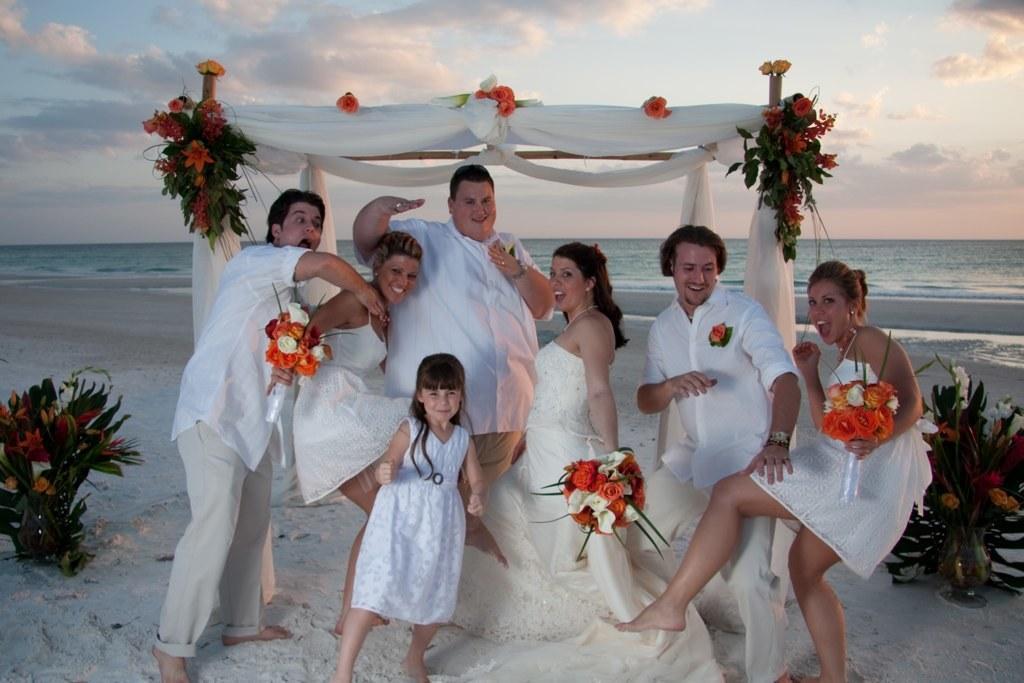In one or two sentences, can you explain what this image depicts? In this image I can see some people are on the seashore, some people are holding flowers in hands. 